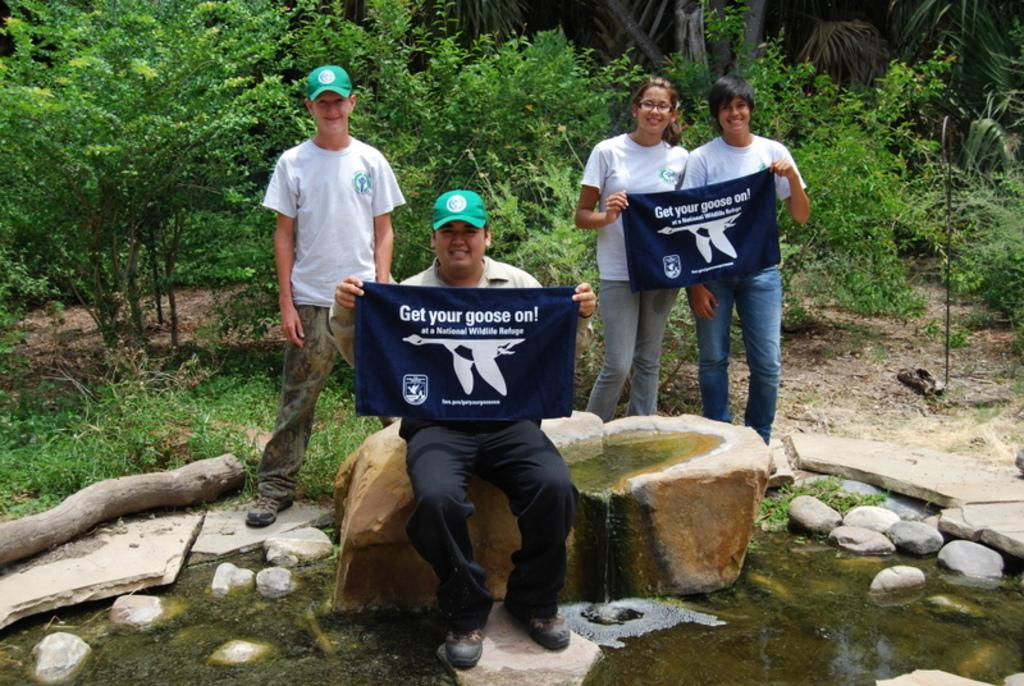<image>
Summarize the visual content of the image. A group of people stand together holding up sings that say get your goose on. 